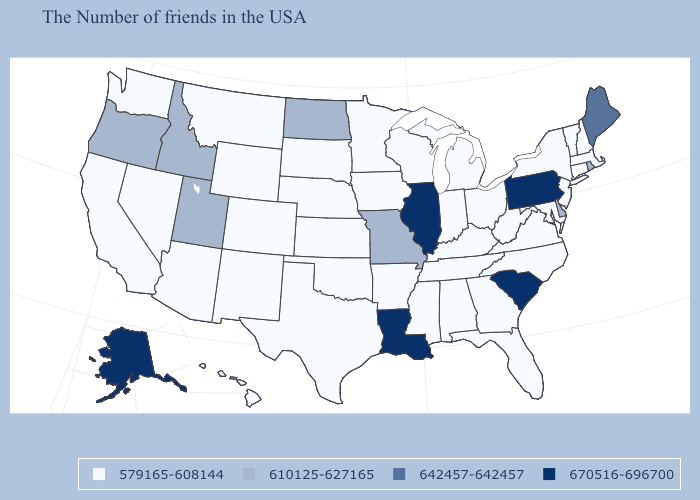What is the value of North Dakota?
Short answer required. 610125-627165. Which states hav the highest value in the MidWest?
Keep it brief. Illinois. Does California have the lowest value in the West?
Write a very short answer. Yes. Name the states that have a value in the range 670516-696700?
Concise answer only. Pennsylvania, South Carolina, Illinois, Louisiana, Alaska. Which states hav the highest value in the West?
Answer briefly. Alaska. Is the legend a continuous bar?
Write a very short answer. No. Name the states that have a value in the range 579165-608144?
Be succinct. Massachusetts, New Hampshire, Vermont, Connecticut, New York, New Jersey, Maryland, Virginia, North Carolina, West Virginia, Ohio, Florida, Georgia, Michigan, Kentucky, Indiana, Alabama, Tennessee, Wisconsin, Mississippi, Arkansas, Minnesota, Iowa, Kansas, Nebraska, Oklahoma, Texas, South Dakota, Wyoming, Colorado, New Mexico, Montana, Arizona, Nevada, California, Washington, Hawaii. Name the states that have a value in the range 579165-608144?
Answer briefly. Massachusetts, New Hampshire, Vermont, Connecticut, New York, New Jersey, Maryland, Virginia, North Carolina, West Virginia, Ohio, Florida, Georgia, Michigan, Kentucky, Indiana, Alabama, Tennessee, Wisconsin, Mississippi, Arkansas, Minnesota, Iowa, Kansas, Nebraska, Oklahoma, Texas, South Dakota, Wyoming, Colorado, New Mexico, Montana, Arizona, Nevada, California, Washington, Hawaii. What is the highest value in the USA?
Write a very short answer. 670516-696700. Name the states that have a value in the range 579165-608144?
Write a very short answer. Massachusetts, New Hampshire, Vermont, Connecticut, New York, New Jersey, Maryland, Virginia, North Carolina, West Virginia, Ohio, Florida, Georgia, Michigan, Kentucky, Indiana, Alabama, Tennessee, Wisconsin, Mississippi, Arkansas, Minnesota, Iowa, Kansas, Nebraska, Oklahoma, Texas, South Dakota, Wyoming, Colorado, New Mexico, Montana, Arizona, Nevada, California, Washington, Hawaii. What is the value of Texas?
Give a very brief answer. 579165-608144. What is the value of North Dakota?
Give a very brief answer. 610125-627165. What is the highest value in the USA?
Concise answer only. 670516-696700. Does Arkansas have a lower value than New Jersey?
Answer briefly. No. Does the first symbol in the legend represent the smallest category?
Write a very short answer. Yes. 